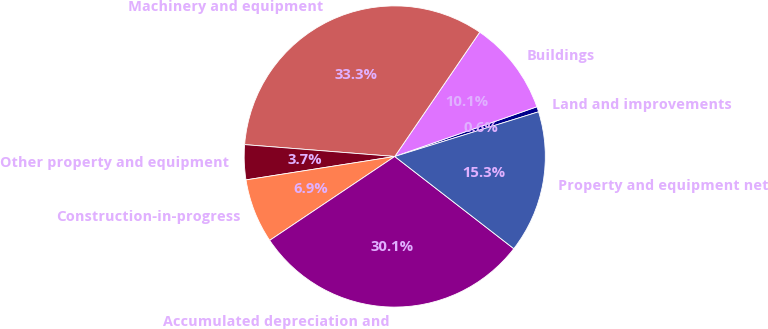Convert chart to OTSL. <chart><loc_0><loc_0><loc_500><loc_500><pie_chart><fcel>Land and improvements<fcel>Buildings<fcel>Machinery and equipment<fcel>Other property and equipment<fcel>Construction-in-progress<fcel>Accumulated depreciation and<fcel>Property and equipment net<nl><fcel>0.56%<fcel>10.1%<fcel>33.29%<fcel>3.74%<fcel>6.92%<fcel>30.11%<fcel>15.28%<nl></chart> 